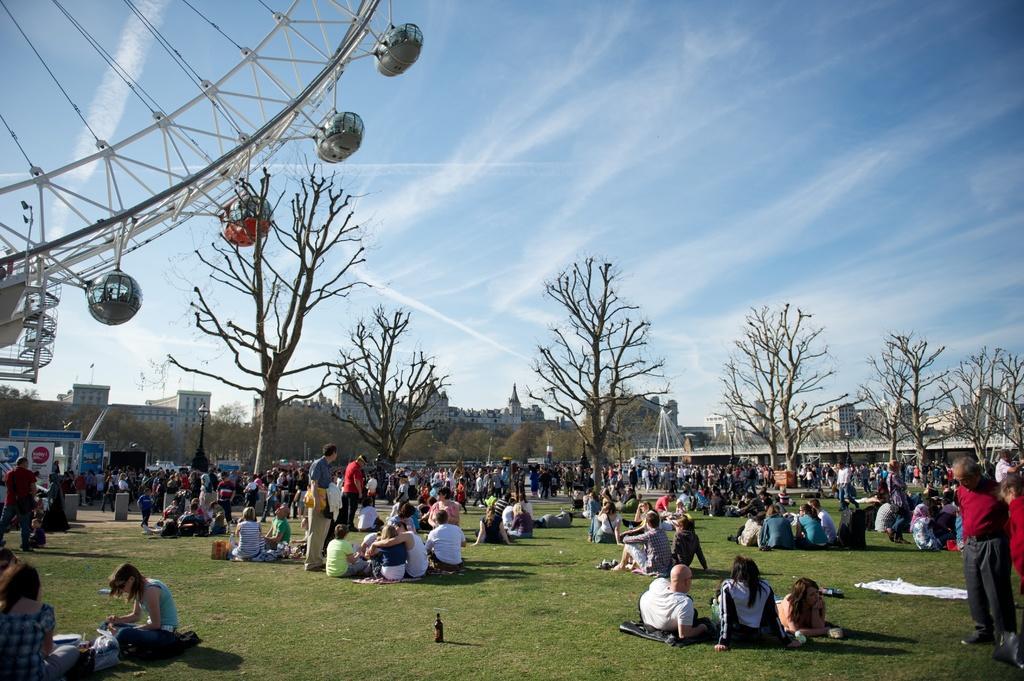Can you describe this image briefly? In this image we can see few people sitting and few people standing on the ground, there is a bottle, cloth and few objects on the ground, there is a giant wheel, there are few buildings, trees and the sky in the background. 